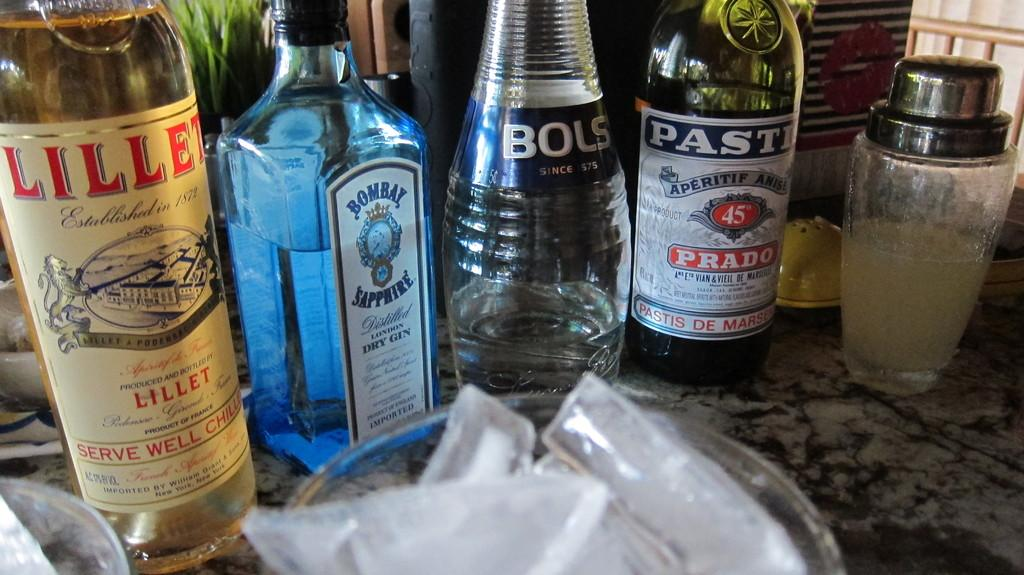What type of furniture is present in the image? There is a table in the image. What objects are on the table? There are bottles, a glass, and a plate on the table. What is on the plate? There are ice cubes on the plate. What type of grain is being played by the band in the image? There is no band or grain present in the image. 